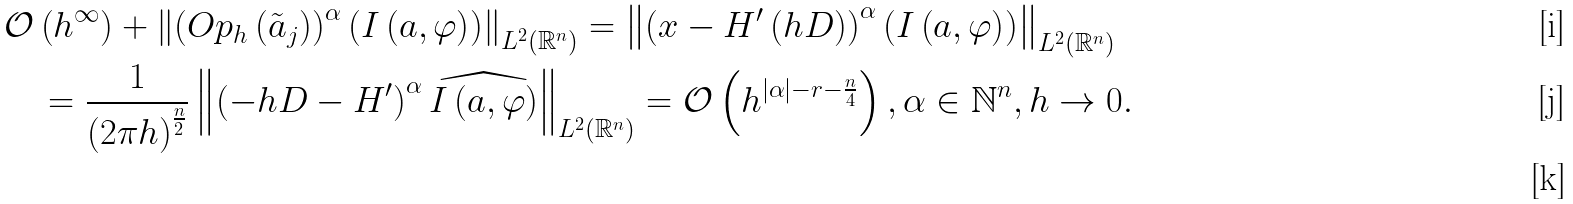Convert formula to latex. <formula><loc_0><loc_0><loc_500><loc_500>& \mathcal { O } \left ( h ^ { \infty } \right ) + \left \| \left ( O p _ { h } \left ( \tilde { a } _ { j } \right ) \right ) ^ { \alpha } \left ( I \left ( a , \varphi \right ) \right ) \right \| _ { L ^ { 2 } \left ( \mathbb { R } ^ { n } \right ) } = \left \| \left ( x - H ^ { \prime } \left ( h D \right ) \right ) ^ { \alpha } \left ( I \left ( a , \varphi \right ) \right ) \right \| _ { L ^ { 2 } \left ( \mathbb { R } ^ { n } \right ) } \\ & \quad = \frac { 1 } { \left ( 2 \pi h \right ) ^ { \frac { n } { 2 } } } \left \| \left ( - h D - H ^ { \prime } \right ) ^ { \alpha } \widehat { I \left ( a , \varphi \right ) } \right \| _ { L ^ { 2 } \left ( \mathbb { R } ^ { n } \right ) } = \mathcal { O } \left ( h ^ { | \alpha | - r - \frac { n } { 4 } } \right ) , \alpha \in \mathbb { N } ^ { n } , h \to 0 . \\</formula> 